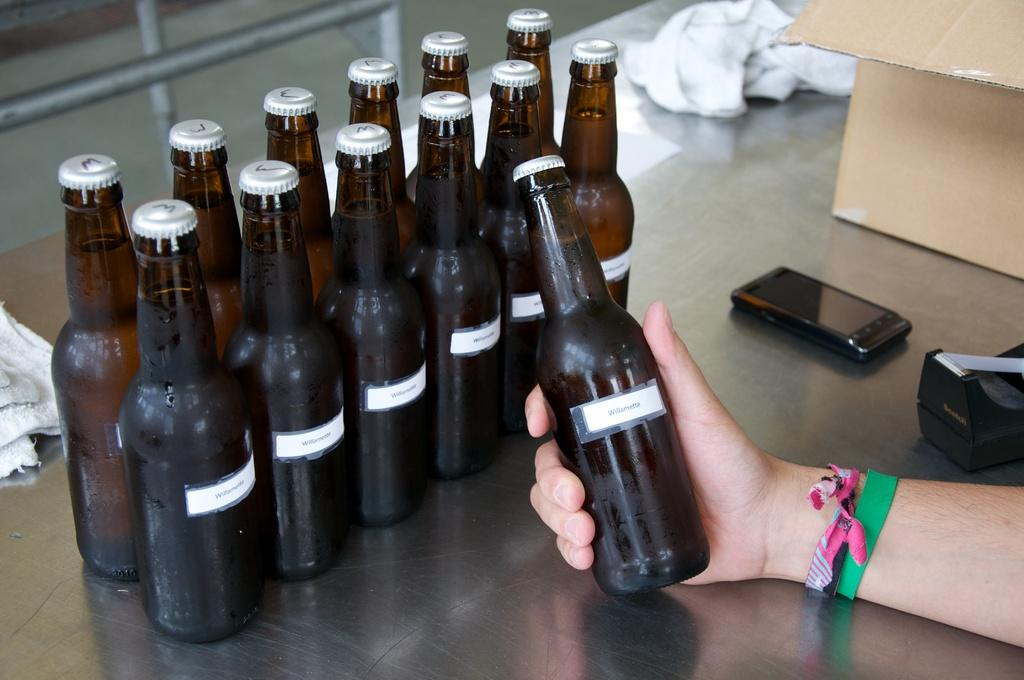What is the main piece of furniture in the image? There is a table in the image. What objects are on the table? There are bottles, a box, a mobile, and a cloth on the table. What is the person in the image doing? A person is holding a bottle. What type of soap is being used to control the mobile in the image? There is no soap or control of the mobile in the image; the mobile is simply on the table. 